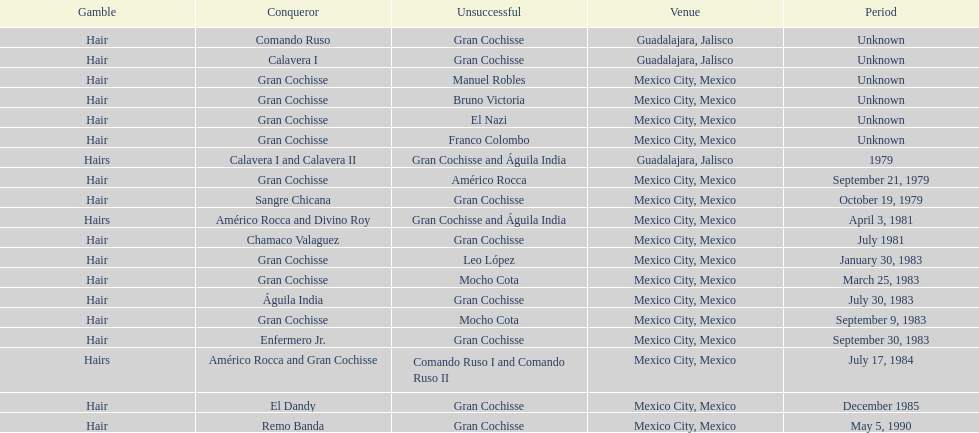When was gran chochisse first match that had a full date on record? September 21, 1979. 